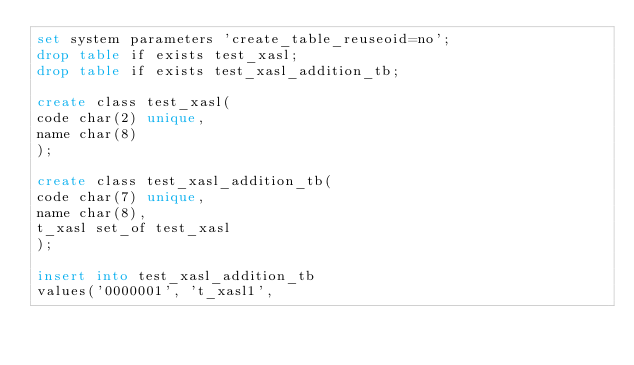<code> <loc_0><loc_0><loc_500><loc_500><_SQL_>set system parameters 'create_table_reuseoid=no';
drop table if exists test_xasl;
drop table if exists test_xasl_addition_tb;

create class test_xasl(
code char(2) unique,
name char(8)
);

create class test_xasl_addition_tb(
code char(7) unique,
name char(8),
t_xasl set_of test_xasl
);

insert into test_xasl_addition_tb
values('0000001', 't_xasl1',</code> 